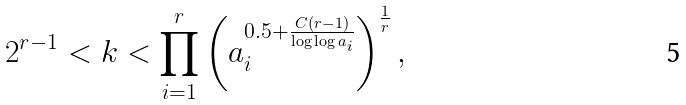<formula> <loc_0><loc_0><loc_500><loc_500>2 ^ { r - 1 } < k < \prod _ { i = 1 } ^ { r } \left ( a _ { i } ^ { 0 . 5 + \frac { C ( r - 1 ) } { \log \log a _ { i } } } \right ) ^ { \frac { 1 } { r } } ,</formula> 